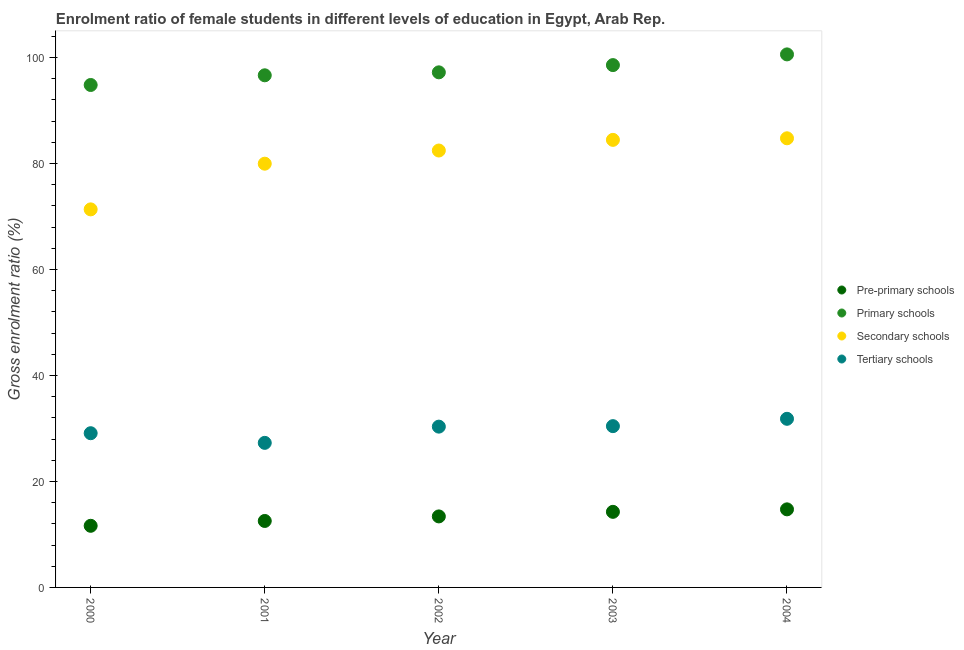Is the number of dotlines equal to the number of legend labels?
Offer a terse response. Yes. What is the gross enrolment ratio(male) in pre-primary schools in 2002?
Keep it short and to the point. 13.4. Across all years, what is the maximum gross enrolment ratio(male) in secondary schools?
Keep it short and to the point. 84.75. Across all years, what is the minimum gross enrolment ratio(male) in pre-primary schools?
Offer a very short reply. 11.63. In which year was the gross enrolment ratio(male) in secondary schools minimum?
Provide a succinct answer. 2000. What is the total gross enrolment ratio(male) in pre-primary schools in the graph?
Give a very brief answer. 66.57. What is the difference between the gross enrolment ratio(male) in primary schools in 2002 and that in 2004?
Offer a very short reply. -3.39. What is the difference between the gross enrolment ratio(male) in primary schools in 2003 and the gross enrolment ratio(male) in tertiary schools in 2002?
Offer a terse response. 68.22. What is the average gross enrolment ratio(male) in pre-primary schools per year?
Your response must be concise. 13.31. In the year 2004, what is the difference between the gross enrolment ratio(male) in pre-primary schools and gross enrolment ratio(male) in primary schools?
Give a very brief answer. -85.85. What is the ratio of the gross enrolment ratio(male) in tertiary schools in 2003 to that in 2004?
Offer a very short reply. 0.96. Is the gross enrolment ratio(male) in tertiary schools in 2002 less than that in 2003?
Keep it short and to the point. Yes. Is the difference between the gross enrolment ratio(male) in tertiary schools in 2001 and 2002 greater than the difference between the gross enrolment ratio(male) in pre-primary schools in 2001 and 2002?
Offer a terse response. No. What is the difference between the highest and the second highest gross enrolment ratio(male) in secondary schools?
Your answer should be compact. 0.3. What is the difference between the highest and the lowest gross enrolment ratio(male) in secondary schools?
Offer a terse response. 13.41. In how many years, is the gross enrolment ratio(male) in secondary schools greater than the average gross enrolment ratio(male) in secondary schools taken over all years?
Provide a short and direct response. 3. Is it the case that in every year, the sum of the gross enrolment ratio(male) in pre-primary schools and gross enrolment ratio(male) in primary schools is greater than the gross enrolment ratio(male) in secondary schools?
Offer a terse response. Yes. Does the gross enrolment ratio(male) in primary schools monotonically increase over the years?
Your answer should be very brief. Yes. Is the gross enrolment ratio(male) in pre-primary schools strictly greater than the gross enrolment ratio(male) in primary schools over the years?
Offer a terse response. No. Is the gross enrolment ratio(male) in tertiary schools strictly less than the gross enrolment ratio(male) in primary schools over the years?
Ensure brevity in your answer.  Yes. How many years are there in the graph?
Give a very brief answer. 5. Are the values on the major ticks of Y-axis written in scientific E-notation?
Offer a very short reply. No. Does the graph contain grids?
Ensure brevity in your answer.  No. How many legend labels are there?
Your answer should be very brief. 4. How are the legend labels stacked?
Your answer should be compact. Vertical. What is the title of the graph?
Your answer should be very brief. Enrolment ratio of female students in different levels of education in Egypt, Arab Rep. What is the label or title of the X-axis?
Your answer should be compact. Year. What is the label or title of the Y-axis?
Your answer should be compact. Gross enrolment ratio (%). What is the Gross enrolment ratio (%) of Pre-primary schools in 2000?
Offer a terse response. 11.63. What is the Gross enrolment ratio (%) of Primary schools in 2000?
Provide a succinct answer. 94.81. What is the Gross enrolment ratio (%) of Secondary schools in 2000?
Your answer should be very brief. 71.34. What is the Gross enrolment ratio (%) of Tertiary schools in 2000?
Provide a succinct answer. 29.1. What is the Gross enrolment ratio (%) of Pre-primary schools in 2001?
Your response must be concise. 12.54. What is the Gross enrolment ratio (%) in Primary schools in 2001?
Keep it short and to the point. 96.64. What is the Gross enrolment ratio (%) in Secondary schools in 2001?
Provide a short and direct response. 79.96. What is the Gross enrolment ratio (%) of Tertiary schools in 2001?
Give a very brief answer. 27.28. What is the Gross enrolment ratio (%) in Pre-primary schools in 2002?
Provide a short and direct response. 13.4. What is the Gross enrolment ratio (%) of Primary schools in 2002?
Make the answer very short. 97.2. What is the Gross enrolment ratio (%) of Secondary schools in 2002?
Give a very brief answer. 82.45. What is the Gross enrolment ratio (%) of Tertiary schools in 2002?
Your response must be concise. 30.34. What is the Gross enrolment ratio (%) in Pre-primary schools in 2003?
Provide a succinct answer. 14.26. What is the Gross enrolment ratio (%) in Primary schools in 2003?
Offer a terse response. 98.57. What is the Gross enrolment ratio (%) in Secondary schools in 2003?
Offer a very short reply. 84.46. What is the Gross enrolment ratio (%) in Tertiary schools in 2003?
Make the answer very short. 30.44. What is the Gross enrolment ratio (%) of Pre-primary schools in 2004?
Provide a succinct answer. 14.73. What is the Gross enrolment ratio (%) of Primary schools in 2004?
Provide a succinct answer. 100.59. What is the Gross enrolment ratio (%) of Secondary schools in 2004?
Provide a succinct answer. 84.75. What is the Gross enrolment ratio (%) in Tertiary schools in 2004?
Give a very brief answer. 31.82. Across all years, what is the maximum Gross enrolment ratio (%) of Pre-primary schools?
Make the answer very short. 14.73. Across all years, what is the maximum Gross enrolment ratio (%) in Primary schools?
Your answer should be compact. 100.59. Across all years, what is the maximum Gross enrolment ratio (%) of Secondary schools?
Offer a very short reply. 84.75. Across all years, what is the maximum Gross enrolment ratio (%) in Tertiary schools?
Your response must be concise. 31.82. Across all years, what is the minimum Gross enrolment ratio (%) of Pre-primary schools?
Your answer should be compact. 11.63. Across all years, what is the minimum Gross enrolment ratio (%) of Primary schools?
Keep it short and to the point. 94.81. Across all years, what is the minimum Gross enrolment ratio (%) in Secondary schools?
Your response must be concise. 71.34. Across all years, what is the minimum Gross enrolment ratio (%) of Tertiary schools?
Your response must be concise. 27.28. What is the total Gross enrolment ratio (%) in Pre-primary schools in the graph?
Offer a very short reply. 66.57. What is the total Gross enrolment ratio (%) of Primary schools in the graph?
Your response must be concise. 487.81. What is the total Gross enrolment ratio (%) of Secondary schools in the graph?
Your answer should be very brief. 402.96. What is the total Gross enrolment ratio (%) in Tertiary schools in the graph?
Your answer should be compact. 148.98. What is the difference between the Gross enrolment ratio (%) of Pre-primary schools in 2000 and that in 2001?
Your response must be concise. -0.91. What is the difference between the Gross enrolment ratio (%) in Primary schools in 2000 and that in 2001?
Your answer should be very brief. -1.83. What is the difference between the Gross enrolment ratio (%) in Secondary schools in 2000 and that in 2001?
Make the answer very short. -8.62. What is the difference between the Gross enrolment ratio (%) of Tertiary schools in 2000 and that in 2001?
Provide a succinct answer. 1.82. What is the difference between the Gross enrolment ratio (%) of Pre-primary schools in 2000 and that in 2002?
Your response must be concise. -1.77. What is the difference between the Gross enrolment ratio (%) in Primary schools in 2000 and that in 2002?
Provide a succinct answer. -2.39. What is the difference between the Gross enrolment ratio (%) of Secondary schools in 2000 and that in 2002?
Provide a succinct answer. -11.11. What is the difference between the Gross enrolment ratio (%) in Tertiary schools in 2000 and that in 2002?
Offer a very short reply. -1.24. What is the difference between the Gross enrolment ratio (%) of Pre-primary schools in 2000 and that in 2003?
Keep it short and to the point. -2.63. What is the difference between the Gross enrolment ratio (%) of Primary schools in 2000 and that in 2003?
Give a very brief answer. -3.75. What is the difference between the Gross enrolment ratio (%) of Secondary schools in 2000 and that in 2003?
Offer a very short reply. -13.12. What is the difference between the Gross enrolment ratio (%) in Tertiary schools in 2000 and that in 2003?
Offer a terse response. -1.33. What is the difference between the Gross enrolment ratio (%) of Pre-primary schools in 2000 and that in 2004?
Your response must be concise. -3.1. What is the difference between the Gross enrolment ratio (%) in Primary schools in 2000 and that in 2004?
Your answer should be very brief. -5.77. What is the difference between the Gross enrolment ratio (%) of Secondary schools in 2000 and that in 2004?
Give a very brief answer. -13.41. What is the difference between the Gross enrolment ratio (%) in Tertiary schools in 2000 and that in 2004?
Your answer should be very brief. -2.72. What is the difference between the Gross enrolment ratio (%) of Pre-primary schools in 2001 and that in 2002?
Offer a very short reply. -0.86. What is the difference between the Gross enrolment ratio (%) in Primary schools in 2001 and that in 2002?
Offer a terse response. -0.56. What is the difference between the Gross enrolment ratio (%) of Secondary schools in 2001 and that in 2002?
Ensure brevity in your answer.  -2.48. What is the difference between the Gross enrolment ratio (%) of Tertiary schools in 2001 and that in 2002?
Make the answer very short. -3.06. What is the difference between the Gross enrolment ratio (%) in Pre-primary schools in 2001 and that in 2003?
Your answer should be compact. -1.72. What is the difference between the Gross enrolment ratio (%) in Primary schools in 2001 and that in 2003?
Provide a short and direct response. -1.92. What is the difference between the Gross enrolment ratio (%) in Secondary schools in 2001 and that in 2003?
Provide a short and direct response. -4.49. What is the difference between the Gross enrolment ratio (%) in Tertiary schools in 2001 and that in 2003?
Your response must be concise. -3.16. What is the difference between the Gross enrolment ratio (%) of Pre-primary schools in 2001 and that in 2004?
Your answer should be very brief. -2.19. What is the difference between the Gross enrolment ratio (%) in Primary schools in 2001 and that in 2004?
Offer a very short reply. -3.95. What is the difference between the Gross enrolment ratio (%) of Secondary schools in 2001 and that in 2004?
Provide a short and direct response. -4.79. What is the difference between the Gross enrolment ratio (%) in Tertiary schools in 2001 and that in 2004?
Your answer should be very brief. -4.54. What is the difference between the Gross enrolment ratio (%) of Pre-primary schools in 2002 and that in 2003?
Provide a succinct answer. -0.86. What is the difference between the Gross enrolment ratio (%) of Primary schools in 2002 and that in 2003?
Make the answer very short. -1.37. What is the difference between the Gross enrolment ratio (%) in Secondary schools in 2002 and that in 2003?
Provide a succinct answer. -2.01. What is the difference between the Gross enrolment ratio (%) of Tertiary schools in 2002 and that in 2003?
Your response must be concise. -0.09. What is the difference between the Gross enrolment ratio (%) in Pre-primary schools in 2002 and that in 2004?
Give a very brief answer. -1.33. What is the difference between the Gross enrolment ratio (%) of Primary schools in 2002 and that in 2004?
Offer a terse response. -3.39. What is the difference between the Gross enrolment ratio (%) in Secondary schools in 2002 and that in 2004?
Offer a very short reply. -2.31. What is the difference between the Gross enrolment ratio (%) of Tertiary schools in 2002 and that in 2004?
Offer a terse response. -1.48. What is the difference between the Gross enrolment ratio (%) in Pre-primary schools in 2003 and that in 2004?
Keep it short and to the point. -0.47. What is the difference between the Gross enrolment ratio (%) of Primary schools in 2003 and that in 2004?
Provide a short and direct response. -2.02. What is the difference between the Gross enrolment ratio (%) in Secondary schools in 2003 and that in 2004?
Make the answer very short. -0.3. What is the difference between the Gross enrolment ratio (%) of Tertiary schools in 2003 and that in 2004?
Offer a very short reply. -1.39. What is the difference between the Gross enrolment ratio (%) in Pre-primary schools in 2000 and the Gross enrolment ratio (%) in Primary schools in 2001?
Give a very brief answer. -85.01. What is the difference between the Gross enrolment ratio (%) of Pre-primary schools in 2000 and the Gross enrolment ratio (%) of Secondary schools in 2001?
Offer a terse response. -68.33. What is the difference between the Gross enrolment ratio (%) in Pre-primary schools in 2000 and the Gross enrolment ratio (%) in Tertiary schools in 2001?
Offer a very short reply. -15.65. What is the difference between the Gross enrolment ratio (%) in Primary schools in 2000 and the Gross enrolment ratio (%) in Secondary schools in 2001?
Your answer should be very brief. 14.85. What is the difference between the Gross enrolment ratio (%) in Primary schools in 2000 and the Gross enrolment ratio (%) in Tertiary schools in 2001?
Your response must be concise. 67.53. What is the difference between the Gross enrolment ratio (%) in Secondary schools in 2000 and the Gross enrolment ratio (%) in Tertiary schools in 2001?
Your response must be concise. 44.06. What is the difference between the Gross enrolment ratio (%) of Pre-primary schools in 2000 and the Gross enrolment ratio (%) of Primary schools in 2002?
Your response must be concise. -85.57. What is the difference between the Gross enrolment ratio (%) in Pre-primary schools in 2000 and the Gross enrolment ratio (%) in Secondary schools in 2002?
Provide a short and direct response. -70.82. What is the difference between the Gross enrolment ratio (%) in Pre-primary schools in 2000 and the Gross enrolment ratio (%) in Tertiary schools in 2002?
Your answer should be compact. -18.71. What is the difference between the Gross enrolment ratio (%) in Primary schools in 2000 and the Gross enrolment ratio (%) in Secondary schools in 2002?
Give a very brief answer. 12.37. What is the difference between the Gross enrolment ratio (%) in Primary schools in 2000 and the Gross enrolment ratio (%) in Tertiary schools in 2002?
Give a very brief answer. 64.47. What is the difference between the Gross enrolment ratio (%) of Secondary schools in 2000 and the Gross enrolment ratio (%) of Tertiary schools in 2002?
Your answer should be compact. 41. What is the difference between the Gross enrolment ratio (%) in Pre-primary schools in 2000 and the Gross enrolment ratio (%) in Primary schools in 2003?
Ensure brevity in your answer.  -86.94. What is the difference between the Gross enrolment ratio (%) of Pre-primary schools in 2000 and the Gross enrolment ratio (%) of Secondary schools in 2003?
Give a very brief answer. -72.83. What is the difference between the Gross enrolment ratio (%) in Pre-primary schools in 2000 and the Gross enrolment ratio (%) in Tertiary schools in 2003?
Keep it short and to the point. -18.81. What is the difference between the Gross enrolment ratio (%) of Primary schools in 2000 and the Gross enrolment ratio (%) of Secondary schools in 2003?
Your answer should be compact. 10.36. What is the difference between the Gross enrolment ratio (%) in Primary schools in 2000 and the Gross enrolment ratio (%) in Tertiary schools in 2003?
Give a very brief answer. 64.38. What is the difference between the Gross enrolment ratio (%) of Secondary schools in 2000 and the Gross enrolment ratio (%) of Tertiary schools in 2003?
Your answer should be very brief. 40.91. What is the difference between the Gross enrolment ratio (%) in Pre-primary schools in 2000 and the Gross enrolment ratio (%) in Primary schools in 2004?
Make the answer very short. -88.96. What is the difference between the Gross enrolment ratio (%) in Pre-primary schools in 2000 and the Gross enrolment ratio (%) in Secondary schools in 2004?
Provide a short and direct response. -73.12. What is the difference between the Gross enrolment ratio (%) of Pre-primary schools in 2000 and the Gross enrolment ratio (%) of Tertiary schools in 2004?
Your answer should be very brief. -20.19. What is the difference between the Gross enrolment ratio (%) of Primary schools in 2000 and the Gross enrolment ratio (%) of Secondary schools in 2004?
Give a very brief answer. 10.06. What is the difference between the Gross enrolment ratio (%) in Primary schools in 2000 and the Gross enrolment ratio (%) in Tertiary schools in 2004?
Your answer should be very brief. 62.99. What is the difference between the Gross enrolment ratio (%) in Secondary schools in 2000 and the Gross enrolment ratio (%) in Tertiary schools in 2004?
Your answer should be compact. 39.52. What is the difference between the Gross enrolment ratio (%) of Pre-primary schools in 2001 and the Gross enrolment ratio (%) of Primary schools in 2002?
Make the answer very short. -84.66. What is the difference between the Gross enrolment ratio (%) in Pre-primary schools in 2001 and the Gross enrolment ratio (%) in Secondary schools in 2002?
Offer a very short reply. -69.91. What is the difference between the Gross enrolment ratio (%) of Pre-primary schools in 2001 and the Gross enrolment ratio (%) of Tertiary schools in 2002?
Offer a terse response. -17.8. What is the difference between the Gross enrolment ratio (%) in Primary schools in 2001 and the Gross enrolment ratio (%) in Secondary schools in 2002?
Make the answer very short. 14.19. What is the difference between the Gross enrolment ratio (%) of Primary schools in 2001 and the Gross enrolment ratio (%) of Tertiary schools in 2002?
Ensure brevity in your answer.  66.3. What is the difference between the Gross enrolment ratio (%) of Secondary schools in 2001 and the Gross enrolment ratio (%) of Tertiary schools in 2002?
Your response must be concise. 49.62. What is the difference between the Gross enrolment ratio (%) in Pre-primary schools in 2001 and the Gross enrolment ratio (%) in Primary schools in 2003?
Offer a very short reply. -86.02. What is the difference between the Gross enrolment ratio (%) of Pre-primary schools in 2001 and the Gross enrolment ratio (%) of Secondary schools in 2003?
Your answer should be compact. -71.92. What is the difference between the Gross enrolment ratio (%) of Pre-primary schools in 2001 and the Gross enrolment ratio (%) of Tertiary schools in 2003?
Give a very brief answer. -17.89. What is the difference between the Gross enrolment ratio (%) of Primary schools in 2001 and the Gross enrolment ratio (%) of Secondary schools in 2003?
Keep it short and to the point. 12.18. What is the difference between the Gross enrolment ratio (%) of Primary schools in 2001 and the Gross enrolment ratio (%) of Tertiary schools in 2003?
Keep it short and to the point. 66.21. What is the difference between the Gross enrolment ratio (%) in Secondary schools in 2001 and the Gross enrolment ratio (%) in Tertiary schools in 2003?
Give a very brief answer. 49.53. What is the difference between the Gross enrolment ratio (%) of Pre-primary schools in 2001 and the Gross enrolment ratio (%) of Primary schools in 2004?
Make the answer very short. -88.04. What is the difference between the Gross enrolment ratio (%) of Pre-primary schools in 2001 and the Gross enrolment ratio (%) of Secondary schools in 2004?
Provide a short and direct response. -72.21. What is the difference between the Gross enrolment ratio (%) of Pre-primary schools in 2001 and the Gross enrolment ratio (%) of Tertiary schools in 2004?
Your response must be concise. -19.28. What is the difference between the Gross enrolment ratio (%) of Primary schools in 2001 and the Gross enrolment ratio (%) of Secondary schools in 2004?
Provide a short and direct response. 11.89. What is the difference between the Gross enrolment ratio (%) in Primary schools in 2001 and the Gross enrolment ratio (%) in Tertiary schools in 2004?
Provide a succinct answer. 64.82. What is the difference between the Gross enrolment ratio (%) in Secondary schools in 2001 and the Gross enrolment ratio (%) in Tertiary schools in 2004?
Make the answer very short. 48.14. What is the difference between the Gross enrolment ratio (%) in Pre-primary schools in 2002 and the Gross enrolment ratio (%) in Primary schools in 2003?
Keep it short and to the point. -85.17. What is the difference between the Gross enrolment ratio (%) of Pre-primary schools in 2002 and the Gross enrolment ratio (%) of Secondary schools in 2003?
Your answer should be compact. -71.06. What is the difference between the Gross enrolment ratio (%) of Pre-primary schools in 2002 and the Gross enrolment ratio (%) of Tertiary schools in 2003?
Your response must be concise. -17.03. What is the difference between the Gross enrolment ratio (%) of Primary schools in 2002 and the Gross enrolment ratio (%) of Secondary schools in 2003?
Provide a succinct answer. 12.74. What is the difference between the Gross enrolment ratio (%) in Primary schools in 2002 and the Gross enrolment ratio (%) in Tertiary schools in 2003?
Provide a succinct answer. 66.76. What is the difference between the Gross enrolment ratio (%) of Secondary schools in 2002 and the Gross enrolment ratio (%) of Tertiary schools in 2003?
Make the answer very short. 52.01. What is the difference between the Gross enrolment ratio (%) in Pre-primary schools in 2002 and the Gross enrolment ratio (%) in Primary schools in 2004?
Offer a very short reply. -87.19. What is the difference between the Gross enrolment ratio (%) in Pre-primary schools in 2002 and the Gross enrolment ratio (%) in Secondary schools in 2004?
Offer a terse response. -71.35. What is the difference between the Gross enrolment ratio (%) in Pre-primary schools in 2002 and the Gross enrolment ratio (%) in Tertiary schools in 2004?
Your answer should be very brief. -18.42. What is the difference between the Gross enrolment ratio (%) of Primary schools in 2002 and the Gross enrolment ratio (%) of Secondary schools in 2004?
Your response must be concise. 12.45. What is the difference between the Gross enrolment ratio (%) of Primary schools in 2002 and the Gross enrolment ratio (%) of Tertiary schools in 2004?
Provide a short and direct response. 65.38. What is the difference between the Gross enrolment ratio (%) in Secondary schools in 2002 and the Gross enrolment ratio (%) in Tertiary schools in 2004?
Provide a succinct answer. 50.63. What is the difference between the Gross enrolment ratio (%) of Pre-primary schools in 2003 and the Gross enrolment ratio (%) of Primary schools in 2004?
Provide a succinct answer. -86.32. What is the difference between the Gross enrolment ratio (%) in Pre-primary schools in 2003 and the Gross enrolment ratio (%) in Secondary schools in 2004?
Keep it short and to the point. -70.49. What is the difference between the Gross enrolment ratio (%) of Pre-primary schools in 2003 and the Gross enrolment ratio (%) of Tertiary schools in 2004?
Give a very brief answer. -17.56. What is the difference between the Gross enrolment ratio (%) in Primary schools in 2003 and the Gross enrolment ratio (%) in Secondary schools in 2004?
Your answer should be very brief. 13.81. What is the difference between the Gross enrolment ratio (%) in Primary schools in 2003 and the Gross enrolment ratio (%) in Tertiary schools in 2004?
Keep it short and to the point. 66.75. What is the difference between the Gross enrolment ratio (%) of Secondary schools in 2003 and the Gross enrolment ratio (%) of Tertiary schools in 2004?
Offer a terse response. 52.64. What is the average Gross enrolment ratio (%) in Pre-primary schools per year?
Your response must be concise. 13.31. What is the average Gross enrolment ratio (%) in Primary schools per year?
Provide a succinct answer. 97.56. What is the average Gross enrolment ratio (%) of Secondary schools per year?
Your response must be concise. 80.59. What is the average Gross enrolment ratio (%) in Tertiary schools per year?
Provide a succinct answer. 29.8. In the year 2000, what is the difference between the Gross enrolment ratio (%) of Pre-primary schools and Gross enrolment ratio (%) of Primary schools?
Your response must be concise. -83.18. In the year 2000, what is the difference between the Gross enrolment ratio (%) of Pre-primary schools and Gross enrolment ratio (%) of Secondary schools?
Offer a terse response. -59.71. In the year 2000, what is the difference between the Gross enrolment ratio (%) in Pre-primary schools and Gross enrolment ratio (%) in Tertiary schools?
Your response must be concise. -17.47. In the year 2000, what is the difference between the Gross enrolment ratio (%) in Primary schools and Gross enrolment ratio (%) in Secondary schools?
Keep it short and to the point. 23.47. In the year 2000, what is the difference between the Gross enrolment ratio (%) of Primary schools and Gross enrolment ratio (%) of Tertiary schools?
Keep it short and to the point. 65.71. In the year 2000, what is the difference between the Gross enrolment ratio (%) of Secondary schools and Gross enrolment ratio (%) of Tertiary schools?
Ensure brevity in your answer.  42.24. In the year 2001, what is the difference between the Gross enrolment ratio (%) of Pre-primary schools and Gross enrolment ratio (%) of Primary schools?
Offer a very short reply. -84.1. In the year 2001, what is the difference between the Gross enrolment ratio (%) in Pre-primary schools and Gross enrolment ratio (%) in Secondary schools?
Provide a short and direct response. -67.42. In the year 2001, what is the difference between the Gross enrolment ratio (%) of Pre-primary schools and Gross enrolment ratio (%) of Tertiary schools?
Provide a succinct answer. -14.74. In the year 2001, what is the difference between the Gross enrolment ratio (%) of Primary schools and Gross enrolment ratio (%) of Secondary schools?
Provide a succinct answer. 16.68. In the year 2001, what is the difference between the Gross enrolment ratio (%) in Primary schools and Gross enrolment ratio (%) in Tertiary schools?
Give a very brief answer. 69.36. In the year 2001, what is the difference between the Gross enrolment ratio (%) in Secondary schools and Gross enrolment ratio (%) in Tertiary schools?
Give a very brief answer. 52.68. In the year 2002, what is the difference between the Gross enrolment ratio (%) of Pre-primary schools and Gross enrolment ratio (%) of Primary schools?
Provide a short and direct response. -83.8. In the year 2002, what is the difference between the Gross enrolment ratio (%) of Pre-primary schools and Gross enrolment ratio (%) of Secondary schools?
Give a very brief answer. -69.05. In the year 2002, what is the difference between the Gross enrolment ratio (%) in Pre-primary schools and Gross enrolment ratio (%) in Tertiary schools?
Keep it short and to the point. -16.94. In the year 2002, what is the difference between the Gross enrolment ratio (%) in Primary schools and Gross enrolment ratio (%) in Secondary schools?
Keep it short and to the point. 14.75. In the year 2002, what is the difference between the Gross enrolment ratio (%) of Primary schools and Gross enrolment ratio (%) of Tertiary schools?
Provide a succinct answer. 66.86. In the year 2002, what is the difference between the Gross enrolment ratio (%) of Secondary schools and Gross enrolment ratio (%) of Tertiary schools?
Offer a very short reply. 52.11. In the year 2003, what is the difference between the Gross enrolment ratio (%) of Pre-primary schools and Gross enrolment ratio (%) of Primary schools?
Keep it short and to the point. -84.3. In the year 2003, what is the difference between the Gross enrolment ratio (%) of Pre-primary schools and Gross enrolment ratio (%) of Secondary schools?
Provide a short and direct response. -70.19. In the year 2003, what is the difference between the Gross enrolment ratio (%) of Pre-primary schools and Gross enrolment ratio (%) of Tertiary schools?
Provide a succinct answer. -16.17. In the year 2003, what is the difference between the Gross enrolment ratio (%) of Primary schools and Gross enrolment ratio (%) of Secondary schools?
Offer a terse response. 14.11. In the year 2003, what is the difference between the Gross enrolment ratio (%) in Primary schools and Gross enrolment ratio (%) in Tertiary schools?
Give a very brief answer. 68.13. In the year 2003, what is the difference between the Gross enrolment ratio (%) in Secondary schools and Gross enrolment ratio (%) in Tertiary schools?
Your answer should be very brief. 54.02. In the year 2004, what is the difference between the Gross enrolment ratio (%) of Pre-primary schools and Gross enrolment ratio (%) of Primary schools?
Your answer should be compact. -85.85. In the year 2004, what is the difference between the Gross enrolment ratio (%) in Pre-primary schools and Gross enrolment ratio (%) in Secondary schools?
Your answer should be compact. -70.02. In the year 2004, what is the difference between the Gross enrolment ratio (%) in Pre-primary schools and Gross enrolment ratio (%) in Tertiary schools?
Your answer should be very brief. -17.09. In the year 2004, what is the difference between the Gross enrolment ratio (%) of Primary schools and Gross enrolment ratio (%) of Secondary schools?
Your answer should be compact. 15.83. In the year 2004, what is the difference between the Gross enrolment ratio (%) in Primary schools and Gross enrolment ratio (%) in Tertiary schools?
Your answer should be very brief. 68.77. In the year 2004, what is the difference between the Gross enrolment ratio (%) in Secondary schools and Gross enrolment ratio (%) in Tertiary schools?
Your response must be concise. 52.93. What is the ratio of the Gross enrolment ratio (%) of Pre-primary schools in 2000 to that in 2001?
Ensure brevity in your answer.  0.93. What is the ratio of the Gross enrolment ratio (%) of Primary schools in 2000 to that in 2001?
Provide a short and direct response. 0.98. What is the ratio of the Gross enrolment ratio (%) in Secondary schools in 2000 to that in 2001?
Offer a terse response. 0.89. What is the ratio of the Gross enrolment ratio (%) in Tertiary schools in 2000 to that in 2001?
Make the answer very short. 1.07. What is the ratio of the Gross enrolment ratio (%) in Pre-primary schools in 2000 to that in 2002?
Your response must be concise. 0.87. What is the ratio of the Gross enrolment ratio (%) of Primary schools in 2000 to that in 2002?
Your answer should be compact. 0.98. What is the ratio of the Gross enrolment ratio (%) of Secondary schools in 2000 to that in 2002?
Provide a short and direct response. 0.87. What is the ratio of the Gross enrolment ratio (%) of Tertiary schools in 2000 to that in 2002?
Make the answer very short. 0.96. What is the ratio of the Gross enrolment ratio (%) in Pre-primary schools in 2000 to that in 2003?
Your response must be concise. 0.82. What is the ratio of the Gross enrolment ratio (%) of Primary schools in 2000 to that in 2003?
Ensure brevity in your answer.  0.96. What is the ratio of the Gross enrolment ratio (%) of Secondary schools in 2000 to that in 2003?
Give a very brief answer. 0.84. What is the ratio of the Gross enrolment ratio (%) in Tertiary schools in 2000 to that in 2003?
Ensure brevity in your answer.  0.96. What is the ratio of the Gross enrolment ratio (%) in Pre-primary schools in 2000 to that in 2004?
Provide a succinct answer. 0.79. What is the ratio of the Gross enrolment ratio (%) of Primary schools in 2000 to that in 2004?
Keep it short and to the point. 0.94. What is the ratio of the Gross enrolment ratio (%) of Secondary schools in 2000 to that in 2004?
Offer a very short reply. 0.84. What is the ratio of the Gross enrolment ratio (%) of Tertiary schools in 2000 to that in 2004?
Keep it short and to the point. 0.91. What is the ratio of the Gross enrolment ratio (%) of Pre-primary schools in 2001 to that in 2002?
Offer a very short reply. 0.94. What is the ratio of the Gross enrolment ratio (%) in Secondary schools in 2001 to that in 2002?
Offer a terse response. 0.97. What is the ratio of the Gross enrolment ratio (%) in Tertiary schools in 2001 to that in 2002?
Keep it short and to the point. 0.9. What is the ratio of the Gross enrolment ratio (%) in Pre-primary schools in 2001 to that in 2003?
Offer a terse response. 0.88. What is the ratio of the Gross enrolment ratio (%) in Primary schools in 2001 to that in 2003?
Give a very brief answer. 0.98. What is the ratio of the Gross enrolment ratio (%) in Secondary schools in 2001 to that in 2003?
Ensure brevity in your answer.  0.95. What is the ratio of the Gross enrolment ratio (%) of Tertiary schools in 2001 to that in 2003?
Make the answer very short. 0.9. What is the ratio of the Gross enrolment ratio (%) of Pre-primary schools in 2001 to that in 2004?
Provide a short and direct response. 0.85. What is the ratio of the Gross enrolment ratio (%) in Primary schools in 2001 to that in 2004?
Offer a very short reply. 0.96. What is the ratio of the Gross enrolment ratio (%) in Secondary schools in 2001 to that in 2004?
Your response must be concise. 0.94. What is the ratio of the Gross enrolment ratio (%) in Tertiary schools in 2001 to that in 2004?
Offer a terse response. 0.86. What is the ratio of the Gross enrolment ratio (%) of Pre-primary schools in 2002 to that in 2003?
Ensure brevity in your answer.  0.94. What is the ratio of the Gross enrolment ratio (%) in Primary schools in 2002 to that in 2003?
Ensure brevity in your answer.  0.99. What is the ratio of the Gross enrolment ratio (%) of Secondary schools in 2002 to that in 2003?
Your response must be concise. 0.98. What is the ratio of the Gross enrolment ratio (%) in Tertiary schools in 2002 to that in 2003?
Your answer should be compact. 1. What is the ratio of the Gross enrolment ratio (%) in Pre-primary schools in 2002 to that in 2004?
Ensure brevity in your answer.  0.91. What is the ratio of the Gross enrolment ratio (%) in Primary schools in 2002 to that in 2004?
Provide a short and direct response. 0.97. What is the ratio of the Gross enrolment ratio (%) of Secondary schools in 2002 to that in 2004?
Give a very brief answer. 0.97. What is the ratio of the Gross enrolment ratio (%) in Tertiary schools in 2002 to that in 2004?
Your response must be concise. 0.95. What is the ratio of the Gross enrolment ratio (%) in Pre-primary schools in 2003 to that in 2004?
Your answer should be compact. 0.97. What is the ratio of the Gross enrolment ratio (%) in Primary schools in 2003 to that in 2004?
Ensure brevity in your answer.  0.98. What is the ratio of the Gross enrolment ratio (%) in Secondary schools in 2003 to that in 2004?
Give a very brief answer. 1. What is the ratio of the Gross enrolment ratio (%) in Tertiary schools in 2003 to that in 2004?
Make the answer very short. 0.96. What is the difference between the highest and the second highest Gross enrolment ratio (%) in Pre-primary schools?
Make the answer very short. 0.47. What is the difference between the highest and the second highest Gross enrolment ratio (%) in Primary schools?
Your response must be concise. 2.02. What is the difference between the highest and the second highest Gross enrolment ratio (%) in Secondary schools?
Your answer should be very brief. 0.3. What is the difference between the highest and the second highest Gross enrolment ratio (%) in Tertiary schools?
Provide a succinct answer. 1.39. What is the difference between the highest and the lowest Gross enrolment ratio (%) in Pre-primary schools?
Ensure brevity in your answer.  3.1. What is the difference between the highest and the lowest Gross enrolment ratio (%) of Primary schools?
Offer a very short reply. 5.77. What is the difference between the highest and the lowest Gross enrolment ratio (%) of Secondary schools?
Provide a short and direct response. 13.41. What is the difference between the highest and the lowest Gross enrolment ratio (%) of Tertiary schools?
Provide a succinct answer. 4.54. 